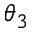Convert formula to latex. <formula><loc_0><loc_0><loc_500><loc_500>\theta _ { 3 }</formula> 